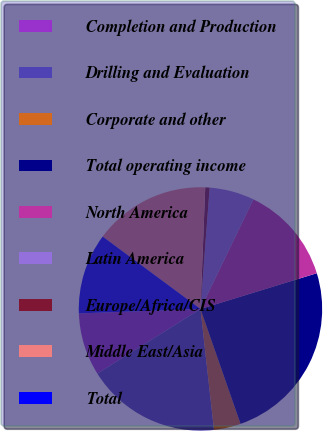Convert chart to OTSL. <chart><loc_0><loc_0><loc_500><loc_500><pie_chart><fcel>Completion and Production<fcel>Drilling and Evaluation<fcel>Corporate and other<fcel>Total operating income<fcel>North America<fcel>Latin America<fcel>Europe/Africa/CIS<fcel>Middle East/Asia<fcel>Total<nl><fcel>8.33%<fcel>17.86%<fcel>3.57%<fcel>24.4%<fcel>13.1%<fcel>5.95%<fcel>0.58%<fcel>15.48%<fcel>10.72%<nl></chart> 